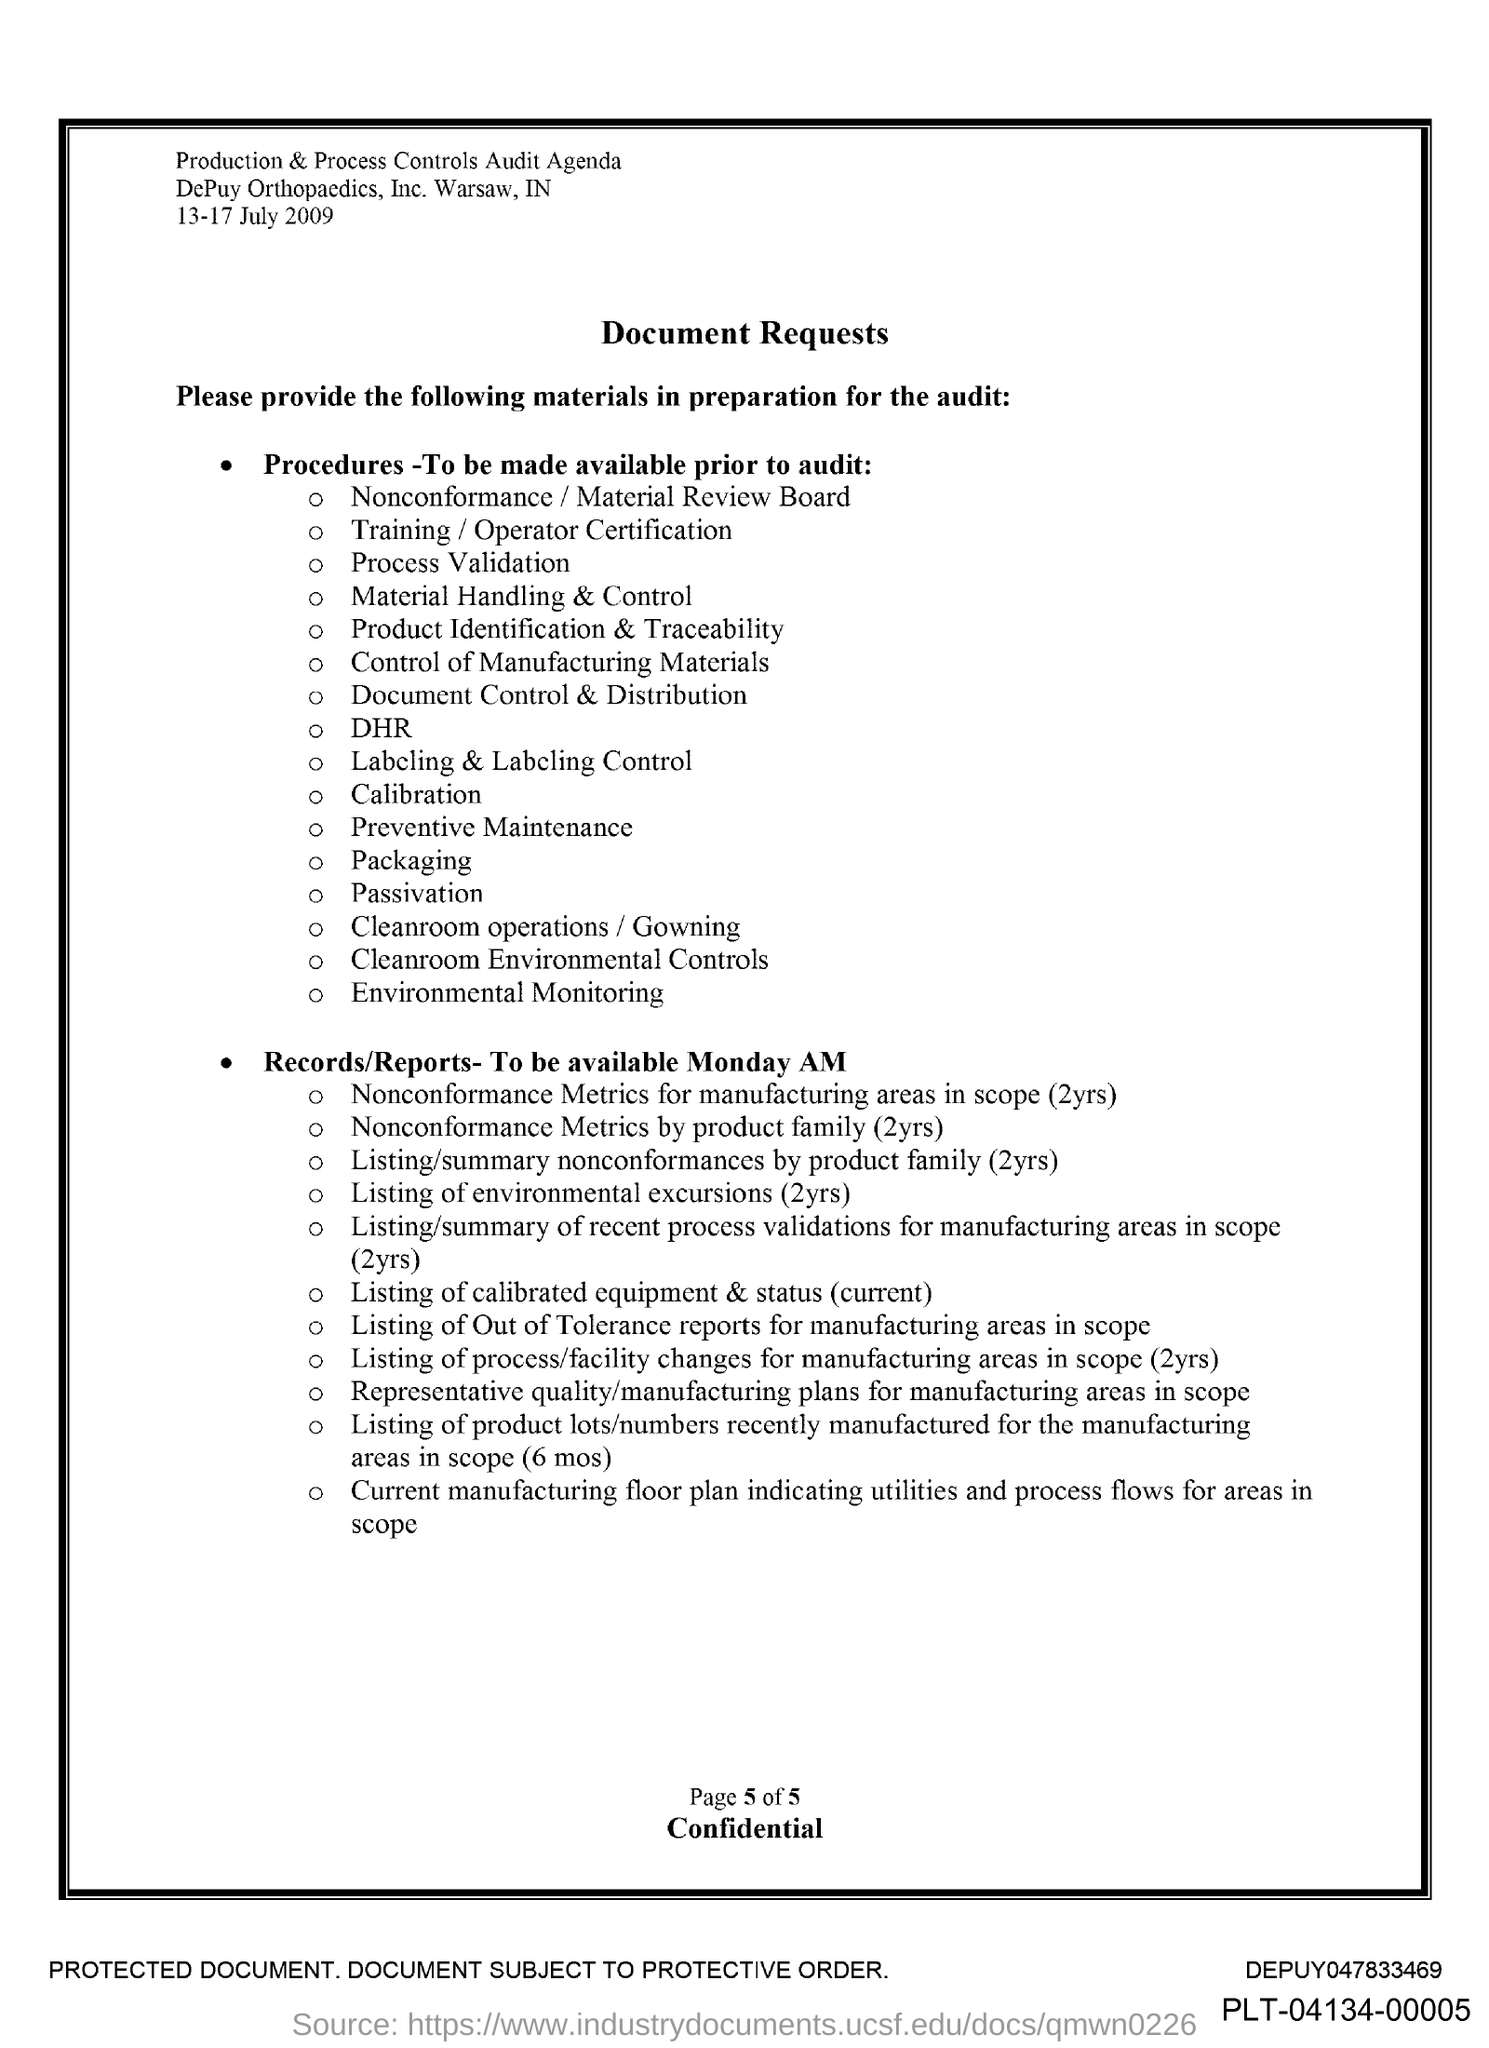Give some essential details in this illustration. The title of the document is 'Document Requests.' The document indicates that the date ranges from 13 to 17 July 2009. 